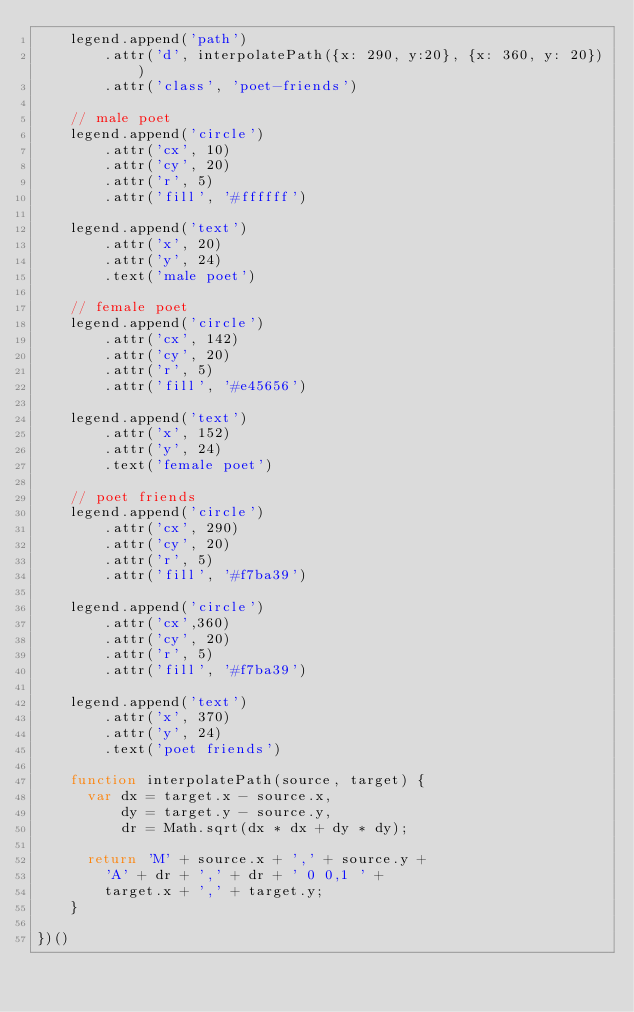<code> <loc_0><loc_0><loc_500><loc_500><_JavaScript_>    legend.append('path')
        .attr('d', interpolatePath({x: 290, y:20}, {x: 360, y: 20}))
        .attr('class', 'poet-friends')

    // male poet
    legend.append('circle')
        .attr('cx', 10)
        .attr('cy', 20)
        .attr('r', 5)
        .attr('fill', '#ffffff')

    legend.append('text')
        .attr('x', 20)
        .attr('y', 24)
        .text('male poet')

    // female poet
    legend.append('circle')
        .attr('cx', 142)
        .attr('cy', 20)
        .attr('r', 5)
        .attr('fill', '#e45656')

    legend.append('text')
        .attr('x', 152)
        .attr('y', 24)
        .text('female poet')

    // poet friends
    legend.append('circle')
        .attr('cx', 290)
        .attr('cy', 20)
        .attr('r', 5)
        .attr('fill', '#f7ba39')

    legend.append('circle')
        .attr('cx',360)
        .attr('cy', 20)
        .attr('r', 5)
        .attr('fill', '#f7ba39')

    legend.append('text')
        .attr('x', 370)
        .attr('y', 24)
        .text('poet friends')

    function interpolatePath(source, target) {
      var dx = target.x - source.x,
          dy = target.y - source.y,
          dr = Math.sqrt(dx * dx + dy * dy);

      return 'M' + source.x + ',' + source.y + 
        'A' + dr + ',' + dr + ' 0 0,1 ' + 
        target.x + ',' + target.y;
    }

})()</code> 